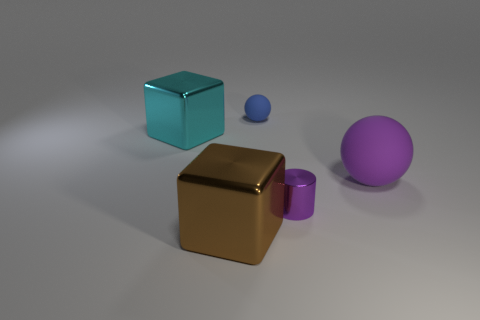Is the color of the metal cylinder the same as the big matte ball?
Your response must be concise. Yes. Is there a purple matte object of the same shape as the blue rubber thing?
Provide a short and direct response. Yes. There is a tiny metal thing; is it the same shape as the big shiny thing that is left of the big brown metal object?
Keep it short and to the point. No. What number of cylinders are either blue matte objects or brown objects?
Provide a succinct answer. 0. There is a shiny object that is behind the purple rubber object; what is its shape?
Provide a succinct answer. Cube. What number of things have the same material as the purple cylinder?
Your answer should be very brief. 2. Is the number of big metal cubes that are on the left side of the brown metallic block less than the number of big metal blocks?
Provide a succinct answer. Yes. What is the size of the shiny object that is on the right side of the matte thing that is behind the cyan block?
Ensure brevity in your answer.  Small. Does the cylinder have the same color as the rubber thing that is on the right side of the blue rubber sphere?
Provide a short and direct response. Yes. What material is the brown thing that is the same size as the cyan metallic thing?
Your answer should be compact. Metal. 